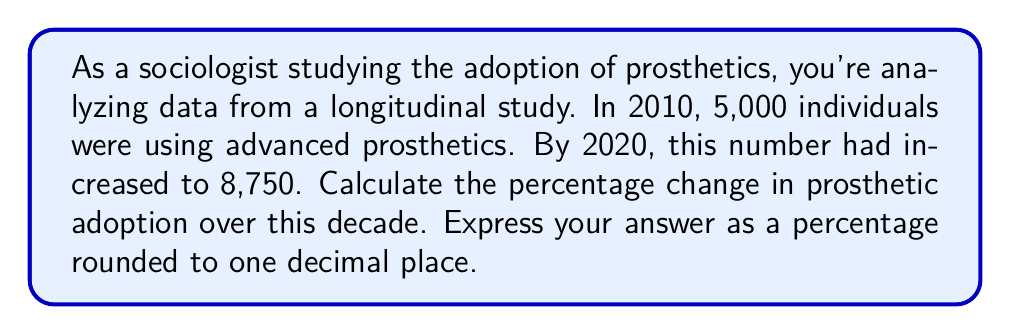Give your solution to this math problem. To calculate the percentage change in prosthetic adoption, we'll use the formula:

$$ \text{Percentage Change} = \frac{\text{New Value} - \text{Original Value}}{\text{Original Value}} \times 100\% $$

Let's break this down step-by-step:

1) Identify the values:
   Original Value (2010): 5,000
   New Value (2020): 8,750

2) Plug these values into the formula:

   $$ \text{Percentage Change} = \frac{8,750 - 5,000}{5,000} \times 100\% $$

3) Simplify the numerator:

   $$ \text{Percentage Change} = \frac{3,750}{5,000} \times 100\% $$

4) Divide:

   $$ \text{Percentage Change} = 0.75 \times 100\% $$

5) Convert to percentage:

   $$ \text{Percentage Change} = 75\% $$

The percentage change is 75%, which means the number of individuals using advanced prosthetics increased by 75% over the decade.
Answer: 75.0% 